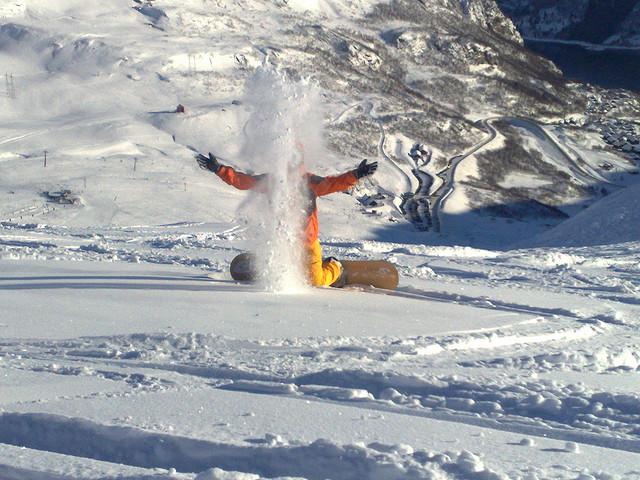Where is the person's face?
Write a very short answer. Behind snow. How many people are in the picture?
Answer briefly. 1. What is the person doing in the middle of the picture?
Keep it brief. Throwing snow. Did the person fall?
Quick response, please. Yes. 